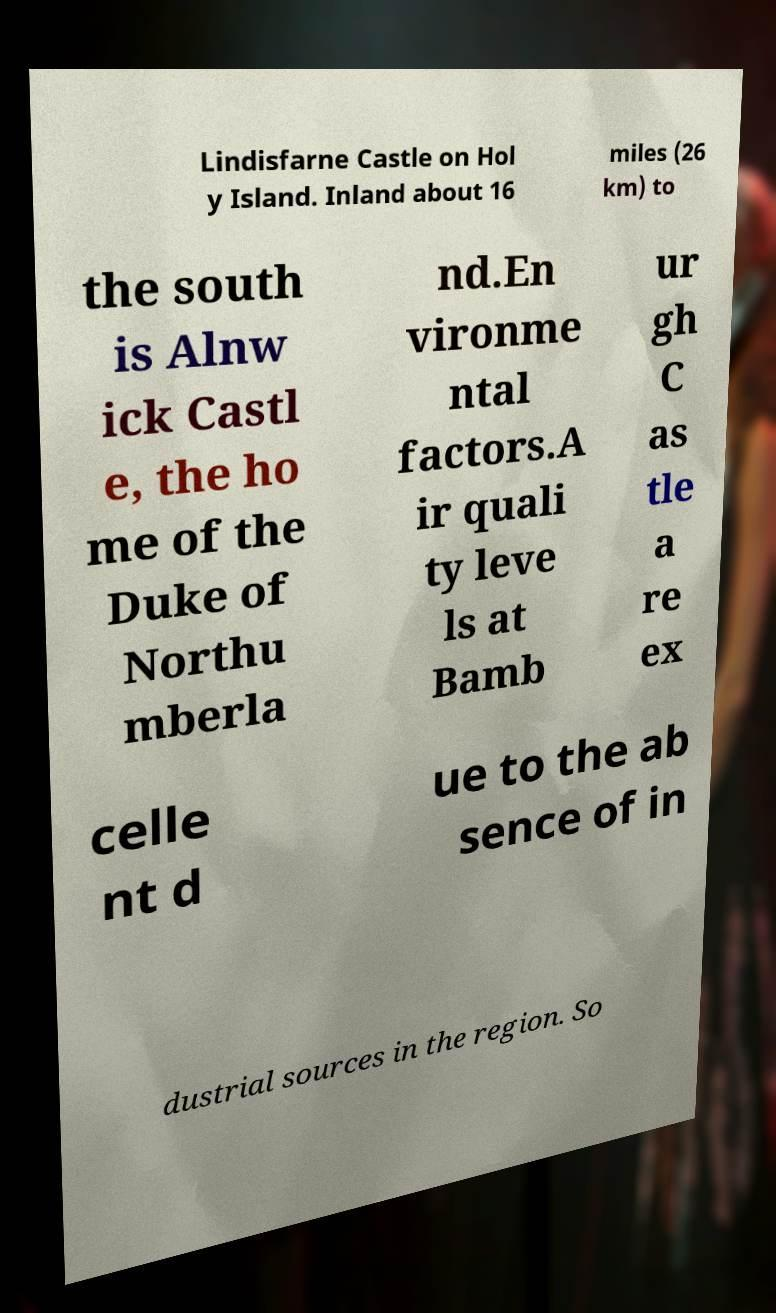There's text embedded in this image that I need extracted. Can you transcribe it verbatim? Lindisfarne Castle on Hol y Island. Inland about 16 miles (26 km) to the south is Alnw ick Castl e, the ho me of the Duke of Northu mberla nd.En vironme ntal factors.A ir quali ty leve ls at Bamb ur gh C as tle a re ex celle nt d ue to the ab sence of in dustrial sources in the region. So 